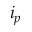<formula> <loc_0><loc_0><loc_500><loc_500>i _ { p }</formula> 